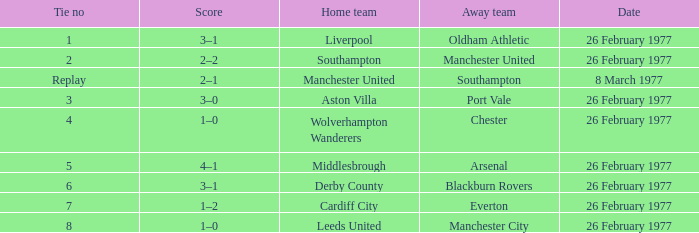Who was the home team that played against Manchester United? Southampton. 